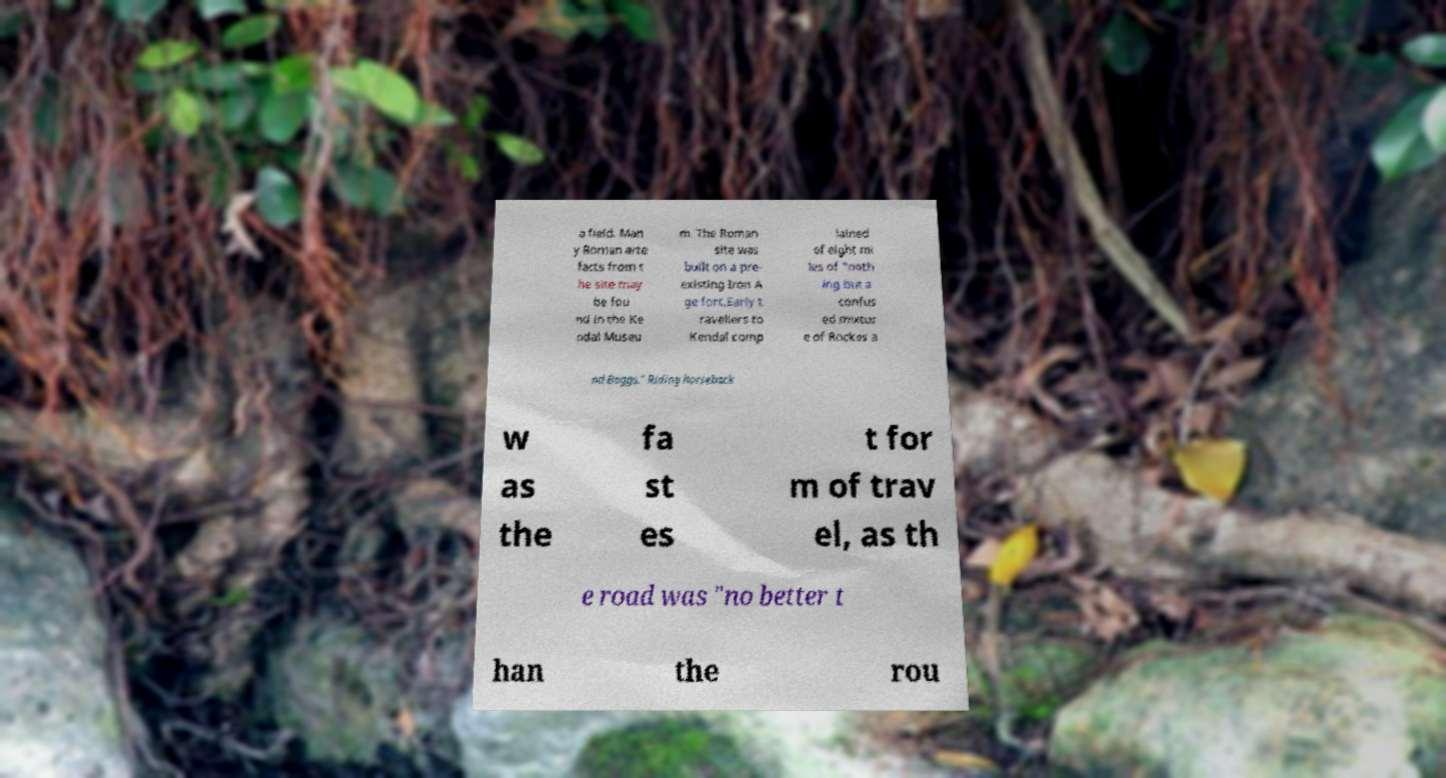Could you assist in decoding the text presented in this image and type it out clearly? a field. Man y Roman arte facts from t he site may be fou nd in the Ke ndal Museu m. The Roman site was built on a pre- existing Iron A ge fort.Early t ravellers to Kendal comp lained of eight mi les of "noth ing but a confus ed mixtur e of Rockes a nd Boggs." Riding horseback w as the fa st es t for m of trav el, as th e road was "no better t han the rou 